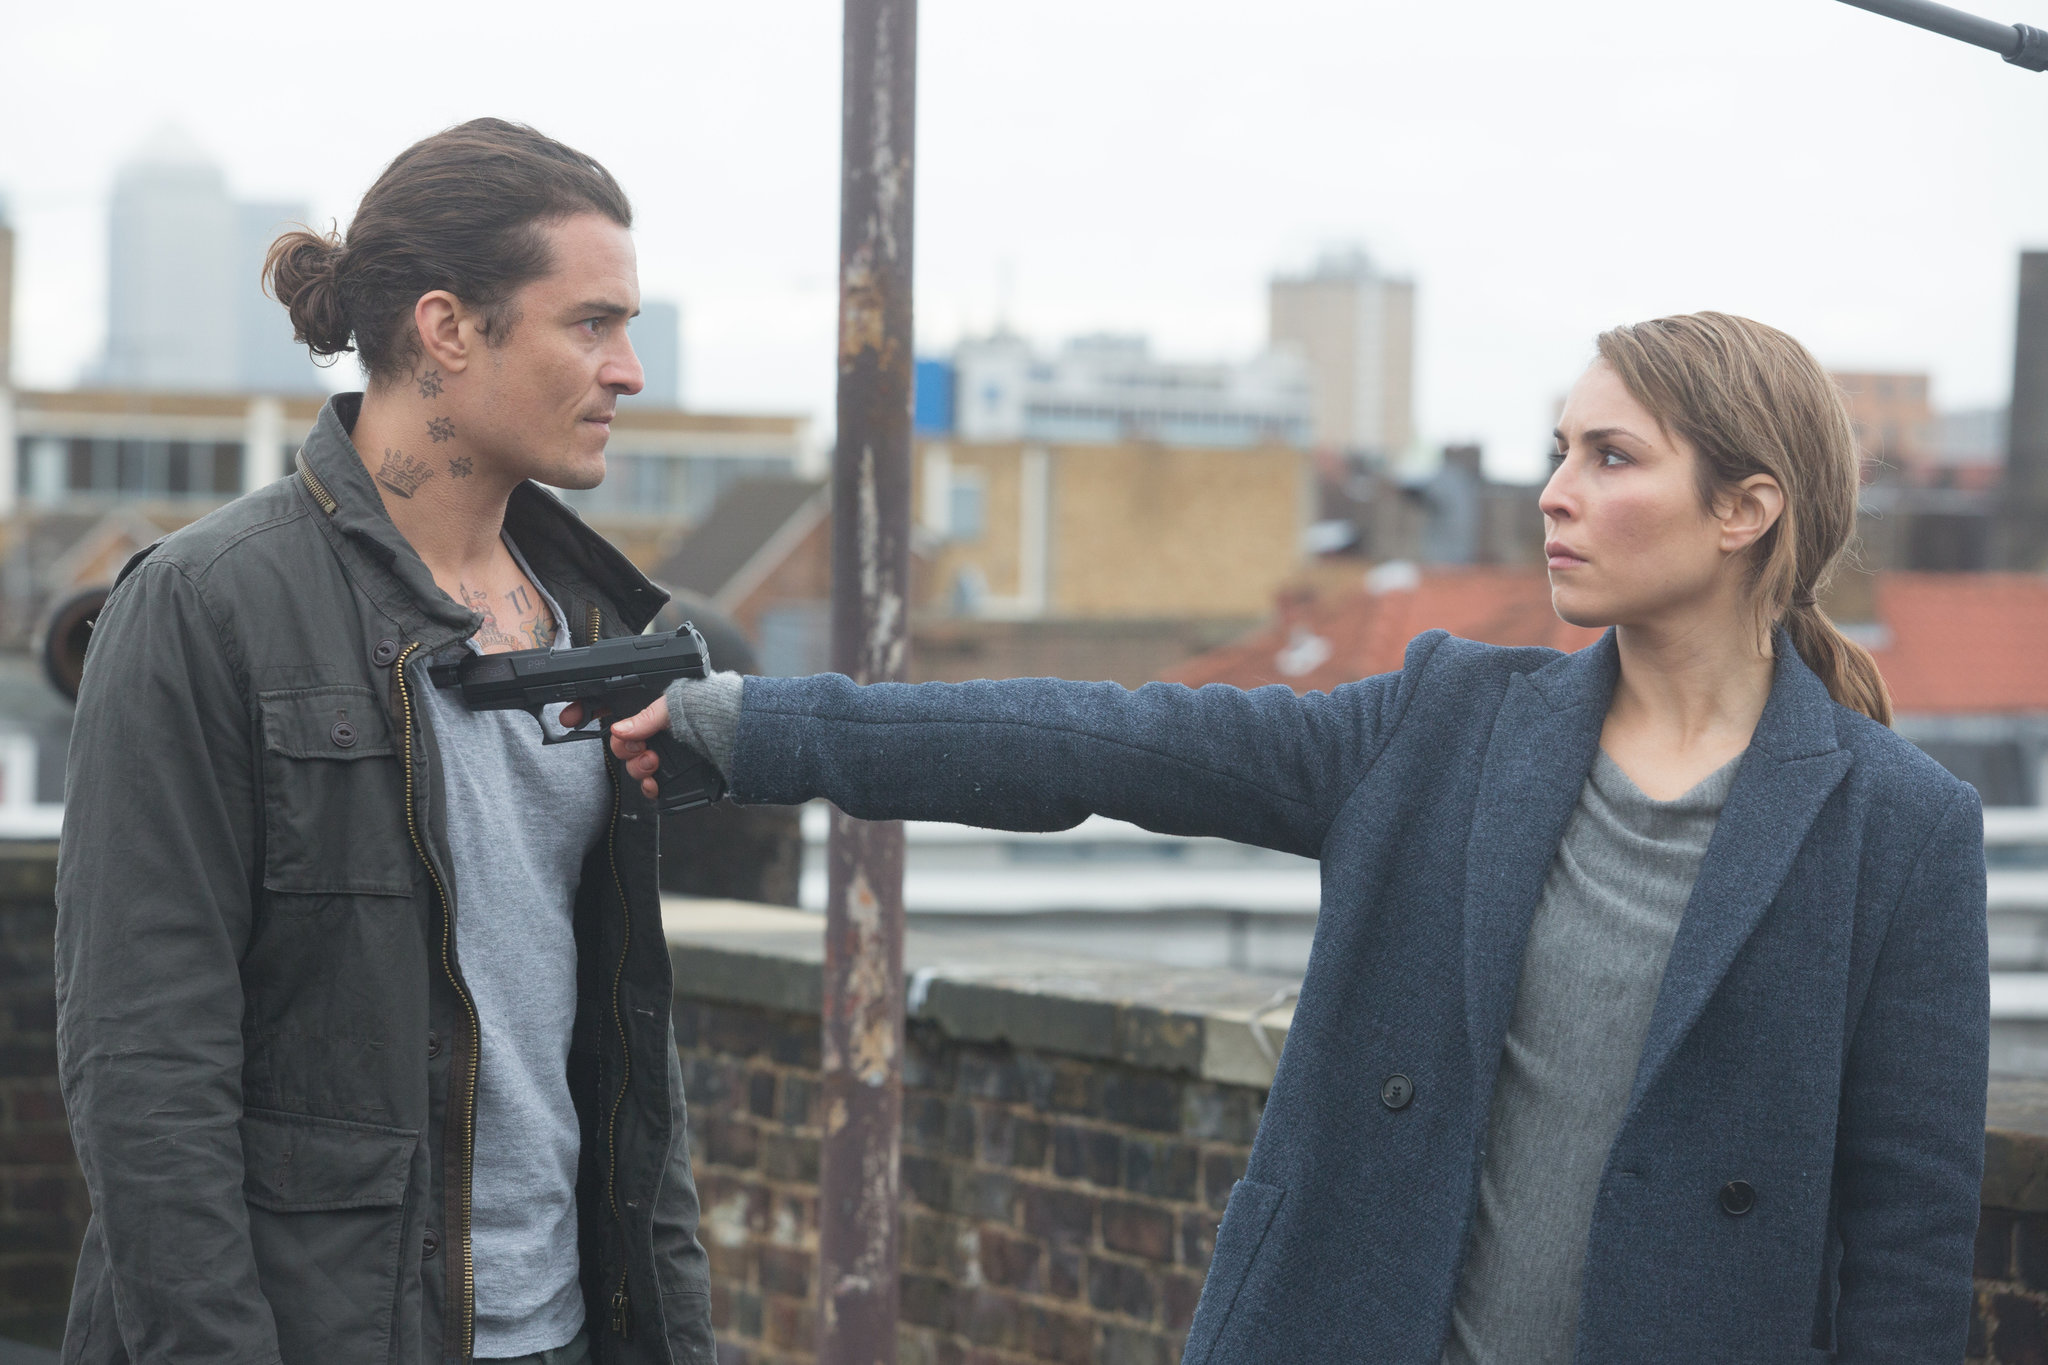Can you elaborate on the symbolism of the urban environment in this scene? The urban backdrop serves as more than just a location; it symbolizes the isolation and harshness that mirror the emotional landscapes of the characters involved. High above the everyday world, this rooftop might represent a final battleground where personal and metaphorical heights are confronted, enhancing the narrative's tension and the stakes of their confrontation. How does the choice of clothing contribute to our understanding of these characters? The clothing choices are stark and telling. Noomi Rapace's character wears a structured, dark coat, suggesting a utilitarian and possibly law-enforcement or security role, aligning with her determined demeanor. In contrast, the man's layered, casual jacket and visible tattoos give him a more rugged, perhaps rebellious appearance, hinting at a life led on the fringes of society or outside conventional norms. 